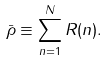Convert formula to latex. <formula><loc_0><loc_0><loc_500><loc_500>\bar { \rho } \equiv \sum _ { n = 1 } ^ { N } R ( n ) .</formula> 